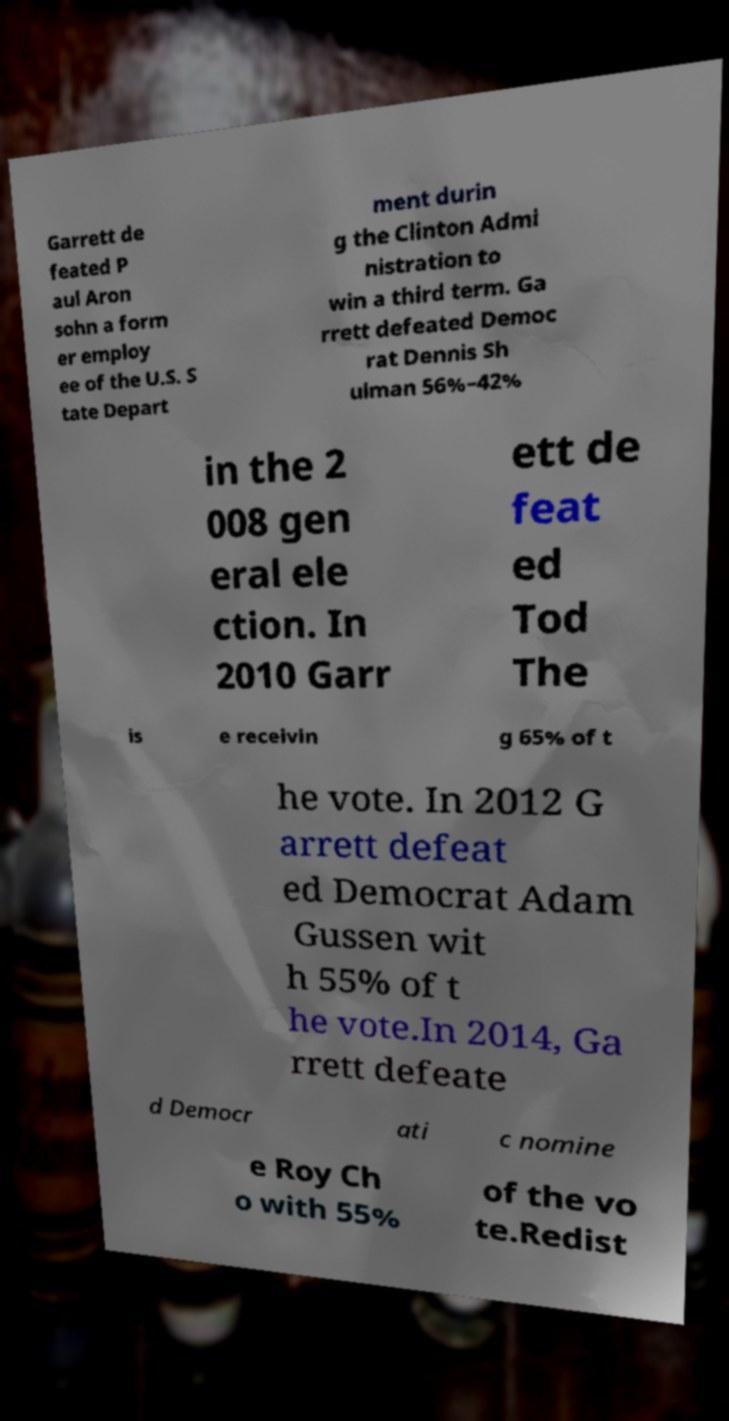There's text embedded in this image that I need extracted. Can you transcribe it verbatim? Garrett de feated P aul Aron sohn a form er employ ee of the U.S. S tate Depart ment durin g the Clinton Admi nistration to win a third term. Ga rrett defeated Democ rat Dennis Sh ulman 56%–42% in the 2 008 gen eral ele ction. In 2010 Garr ett de feat ed Tod The is e receivin g 65% of t he vote. In 2012 G arrett defeat ed Democrat Adam Gussen wit h 55% of t he vote.In 2014, Ga rrett defeate d Democr ati c nomine e Roy Ch o with 55% of the vo te.Redist 